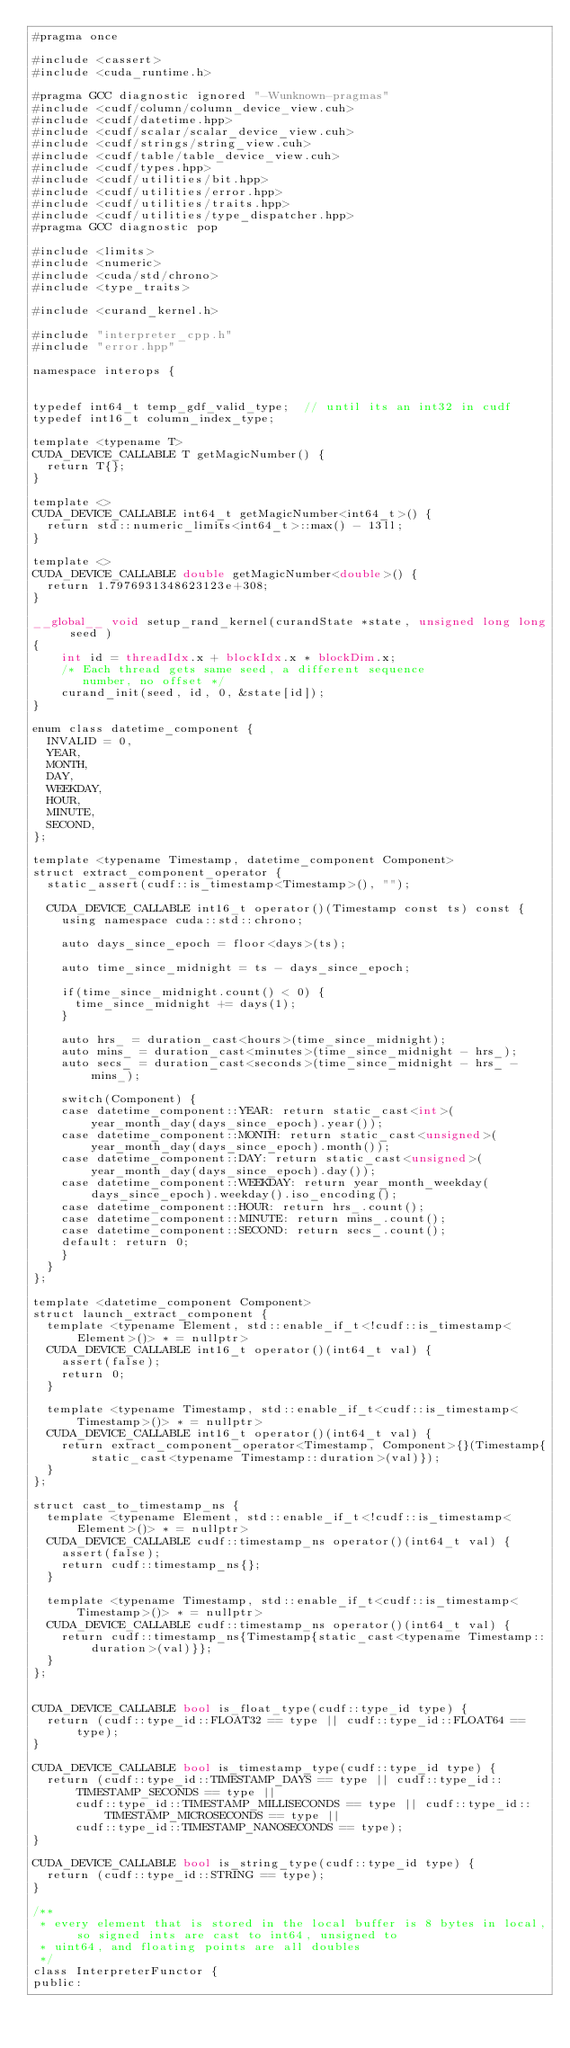Convert code to text. <code><loc_0><loc_0><loc_500><loc_500><_Cuda_>#pragma once

#include <cassert>
#include <cuda_runtime.h>

#pragma GCC diagnostic ignored "-Wunknown-pragmas"
#include <cudf/column/column_device_view.cuh>
#include <cudf/datetime.hpp>
#include <cudf/scalar/scalar_device_view.cuh>
#include <cudf/strings/string_view.cuh>
#include <cudf/table/table_device_view.cuh>
#include <cudf/types.hpp>
#include <cudf/utilities/bit.hpp>
#include <cudf/utilities/error.hpp>
#include <cudf/utilities/traits.hpp>
#include <cudf/utilities/type_dispatcher.hpp>
#pragma GCC diagnostic pop

#include <limits>
#include <numeric>
#include <cuda/std/chrono>
#include <type_traits>

#include <curand_kernel.h>

#include "interpreter_cpp.h"
#include "error.hpp"

namespace interops {


typedef int64_t temp_gdf_valid_type;  // until its an int32 in cudf
typedef int16_t column_index_type;

template <typename T>
CUDA_DEVICE_CALLABLE T getMagicNumber() {
	return T{};
}

template <>
CUDA_DEVICE_CALLABLE int64_t getMagicNumber<int64_t>() {
	return std::numeric_limits<int64_t>::max() - 13ll;
}

template <>
CUDA_DEVICE_CALLABLE double getMagicNumber<double>() {
	return 1.7976931348623123e+308;
}

__global__ void setup_rand_kernel(curandState *state, unsigned long long seed )
{
    int id = threadIdx.x + blockIdx.x * blockDim.x;
    /* Each thread gets same seed, a different sequence
       number, no offset */
    curand_init(seed, id, 0, &state[id]);
}

enum class datetime_component {
  INVALID = 0,
  YEAR,
  MONTH,
  DAY,
  WEEKDAY,
  HOUR,
  MINUTE,
  SECOND,
};

template <typename Timestamp, datetime_component Component>
struct extract_component_operator {
	static_assert(cudf::is_timestamp<Timestamp>(), "");

	CUDA_DEVICE_CALLABLE int16_t operator()(Timestamp const ts) const {
		using namespace cuda::std::chrono;

		auto days_since_epoch = floor<days>(ts);

		auto time_since_midnight = ts - days_since_epoch;

		if(time_since_midnight.count() < 0) {
			time_since_midnight += days(1);
		}

		auto hrs_ = duration_cast<hours>(time_since_midnight);
		auto mins_ = duration_cast<minutes>(time_since_midnight - hrs_);
		auto secs_ = duration_cast<seconds>(time_since_midnight - hrs_ - mins_);

		switch(Component) {
		case datetime_component::YEAR: return static_cast<int>(year_month_day(days_since_epoch).year());
		case datetime_component::MONTH: return static_cast<unsigned>(year_month_day(days_since_epoch).month());
		case datetime_component::DAY: return static_cast<unsigned>(year_month_day(days_since_epoch).day());
		case datetime_component::WEEKDAY: return year_month_weekday(days_since_epoch).weekday().iso_encoding();
		case datetime_component::HOUR: return hrs_.count();
		case datetime_component::MINUTE: return mins_.count();
		case datetime_component::SECOND: return secs_.count();
		default: return 0;
		}
	}
};

template <datetime_component Component>
struct launch_extract_component {
	template <typename Element, std::enable_if_t<!cudf::is_timestamp<Element>()> * = nullptr>
	CUDA_DEVICE_CALLABLE int16_t operator()(int64_t val) {
		assert(false);
		return 0;
	}

	template <typename Timestamp, std::enable_if_t<cudf::is_timestamp<Timestamp>()> * = nullptr>
	CUDA_DEVICE_CALLABLE int16_t operator()(int64_t val) {
		return extract_component_operator<Timestamp, Component>{}(Timestamp{static_cast<typename Timestamp::duration>(val)});
	}
};

struct cast_to_timestamp_ns {
	template <typename Element, std::enable_if_t<!cudf::is_timestamp<Element>()> * = nullptr>
	CUDA_DEVICE_CALLABLE cudf::timestamp_ns operator()(int64_t val) {
		assert(false);
		return cudf::timestamp_ns{};
	}

	template <typename Timestamp, std::enable_if_t<cudf::is_timestamp<Timestamp>()> * = nullptr>
	CUDA_DEVICE_CALLABLE cudf::timestamp_ns operator()(int64_t val) {
		return cudf::timestamp_ns{Timestamp{static_cast<typename Timestamp::duration>(val)}};
	}
};


CUDA_DEVICE_CALLABLE bool is_float_type(cudf::type_id type) {
	return (cudf::type_id::FLOAT32 == type || cudf::type_id::FLOAT64 == type);
}

CUDA_DEVICE_CALLABLE bool is_timestamp_type(cudf::type_id type) {
	return (cudf::type_id::TIMESTAMP_DAYS == type || cudf::type_id::TIMESTAMP_SECONDS == type ||
			cudf::type_id::TIMESTAMP_MILLISECONDS == type || cudf::type_id::TIMESTAMP_MICROSECONDS == type ||
			cudf::type_id::TIMESTAMP_NANOSECONDS == type);
}

CUDA_DEVICE_CALLABLE bool is_string_type(cudf::type_id type) {
	return (cudf::type_id::STRING == type);
}

/**
 * every element that is stored in the local buffer is 8 bytes in local, so signed ints are cast to int64, unsigned to
 * uint64, and floating points are all doubles
 */
class InterpreterFunctor {
public:</code> 